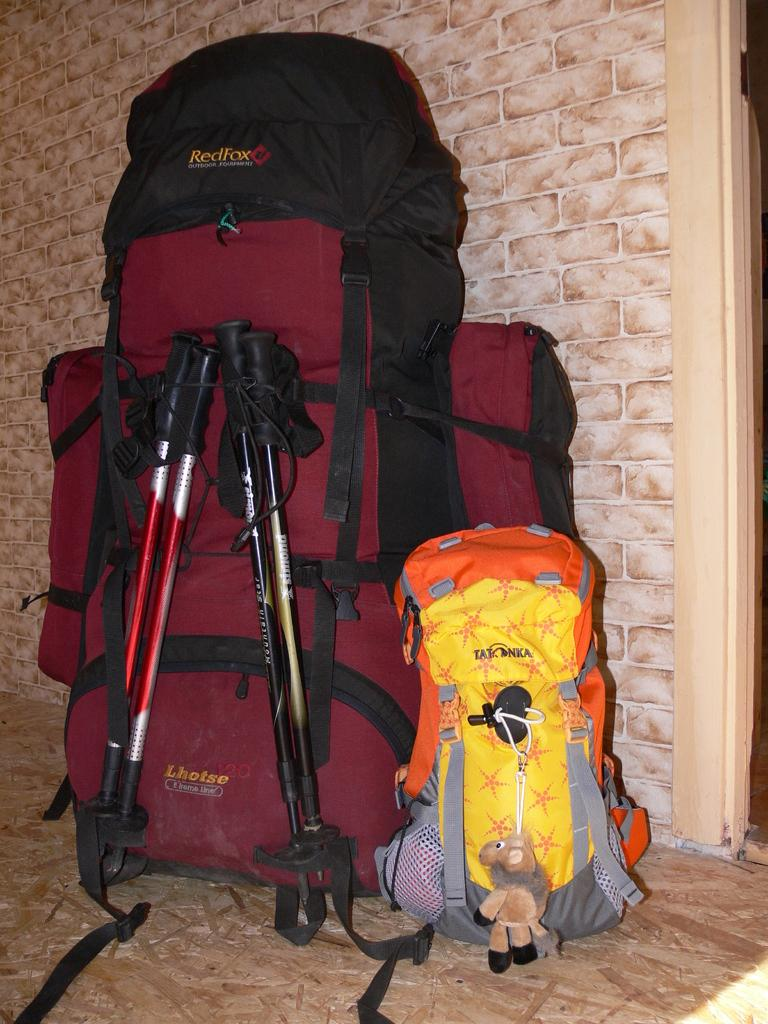<image>
Describe the image concisely. A small stuffed animal hands from a yellow Tatonka bag. 